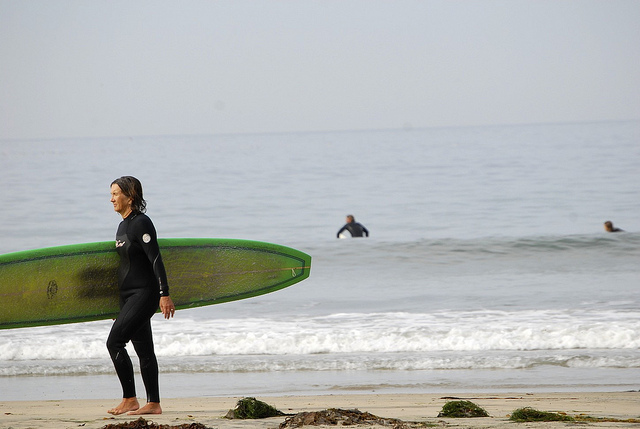How would you describe the weather conditions in the image? The weather conditions in the image appear to be calm and pleasant. The sky is light and clear without any visible clouds, suggesting a day with good visibility. The ocean's surface looks relatively smooth, indicating mild weather, likely without strong winds or rough waves. Can you speculate on the possible season based on the image? Based on the image, it is possible that the season could be early autumn or late spring. The attire of the surfers, who are wearing full wetsuits, suggests that the water temperature might be moderately chilly, which is typical for these transitional seasons. Additionally, the light and clear weather indicate that it is likely not the middle of winter or peak summer. Imagine there is a small island visible in the far distance. How would you describe the scene now? With the addition of a small island visible in the far distance, the scene becomes even more picturesque. The island could appear as a faint silhouette on the horizon, adding depth and an element of distant adventure to the image. This distant island might hint at hidden beaches or unexplored territories, enhancing the overall allure of the surfing experience. If you had to write a short story inspired by this image, what would the plot be? In a scenic coastal town, three friends reunite after years apart for a nostalgic surfing trip. As they gear up, old memories and buried secrets resurface. Amidst the rhythm of the waves, they navigate past misunderstandings, rekindle their bond, and discover new depths in their friendship. The presence of a mysterious island on the horizon fuels their imagination and becomes a symbol of the uncharted journeys they still have to take. By the end of the day, they not only ride the waves, but also the turbulent waters of their shared past, emerging with a deeper understanding and a renewed connection. 